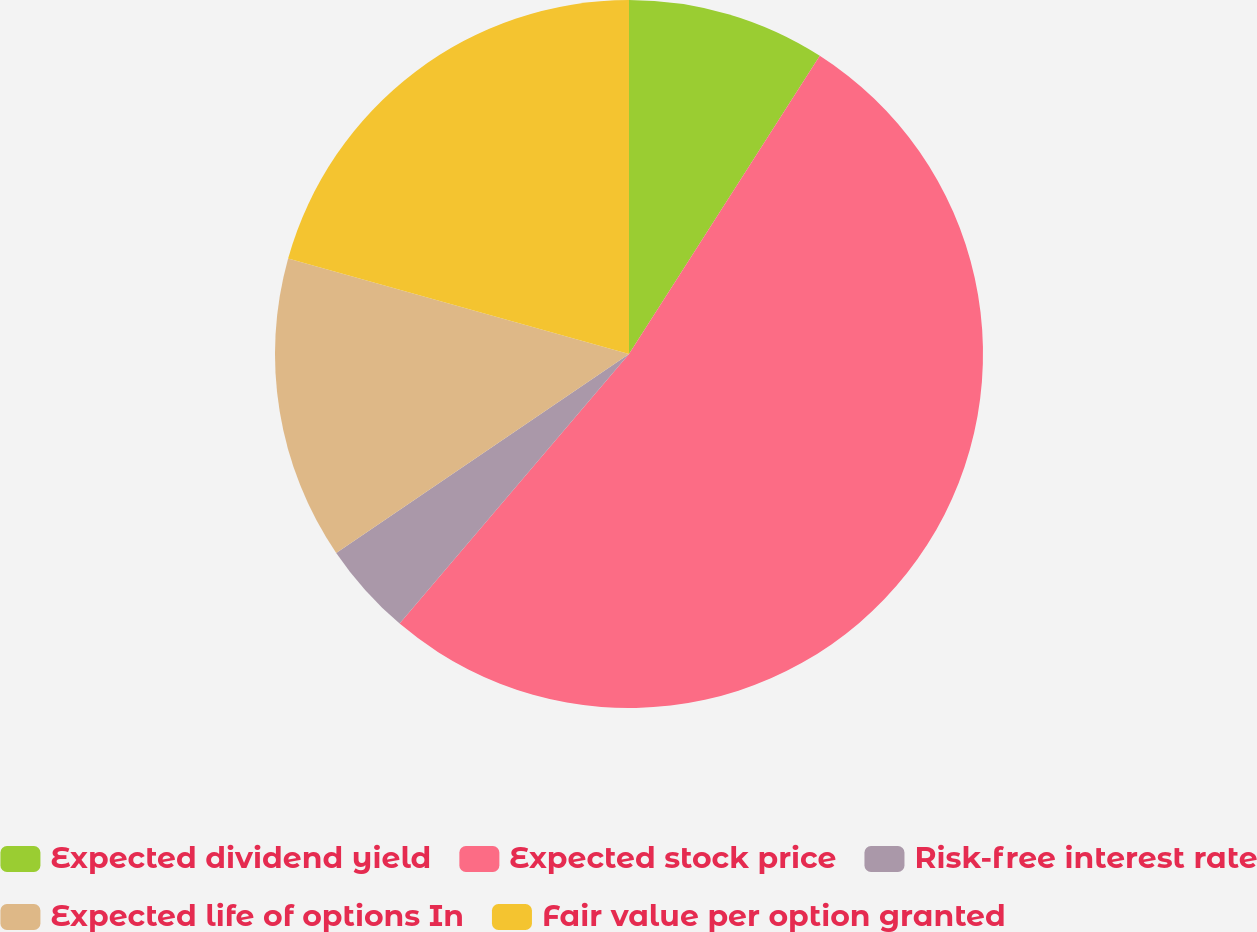Convert chart to OTSL. <chart><loc_0><loc_0><loc_500><loc_500><pie_chart><fcel>Expected dividend yield<fcel>Expected stock price<fcel>Risk-free interest rate<fcel>Expected life of options In<fcel>Fair value per option granted<nl><fcel>9.06%<fcel>52.16%<fcel>4.28%<fcel>13.85%<fcel>20.65%<nl></chart> 